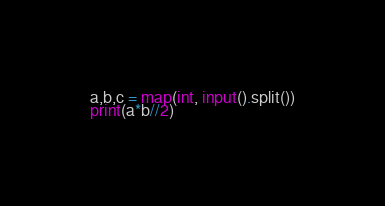Convert code to text. <code><loc_0><loc_0><loc_500><loc_500><_Python_>a,b,c = map(int, input().split())
print(a*b//2)</code> 